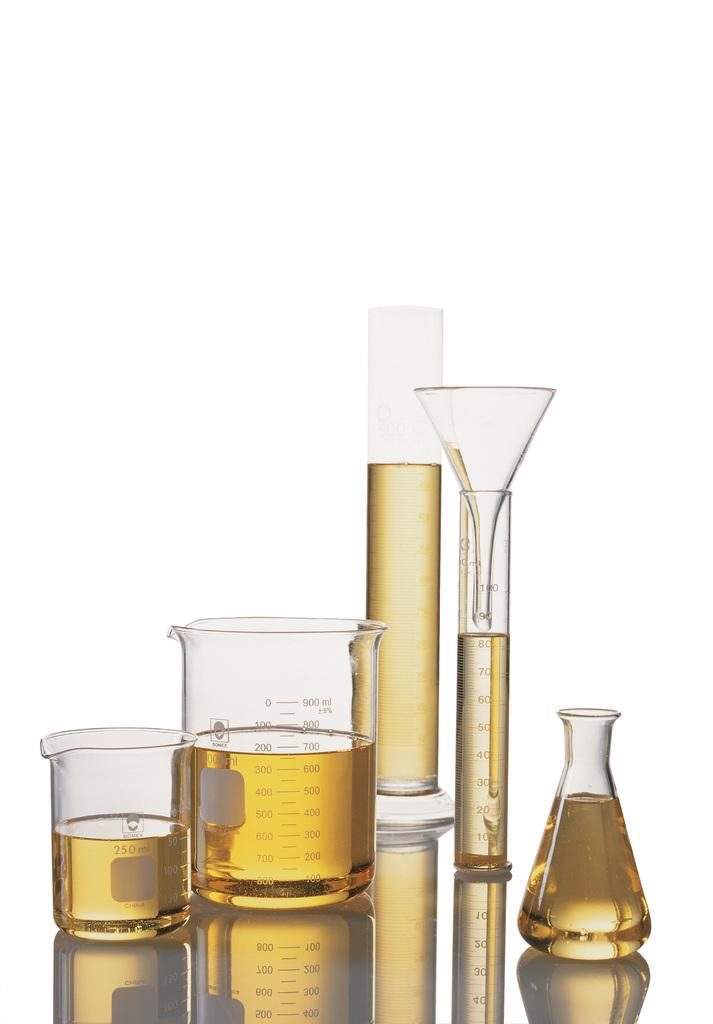Provide a one-sentence caption for the provided image. A collection of chemistry vials, flasks and beakers is made by Bomex. 